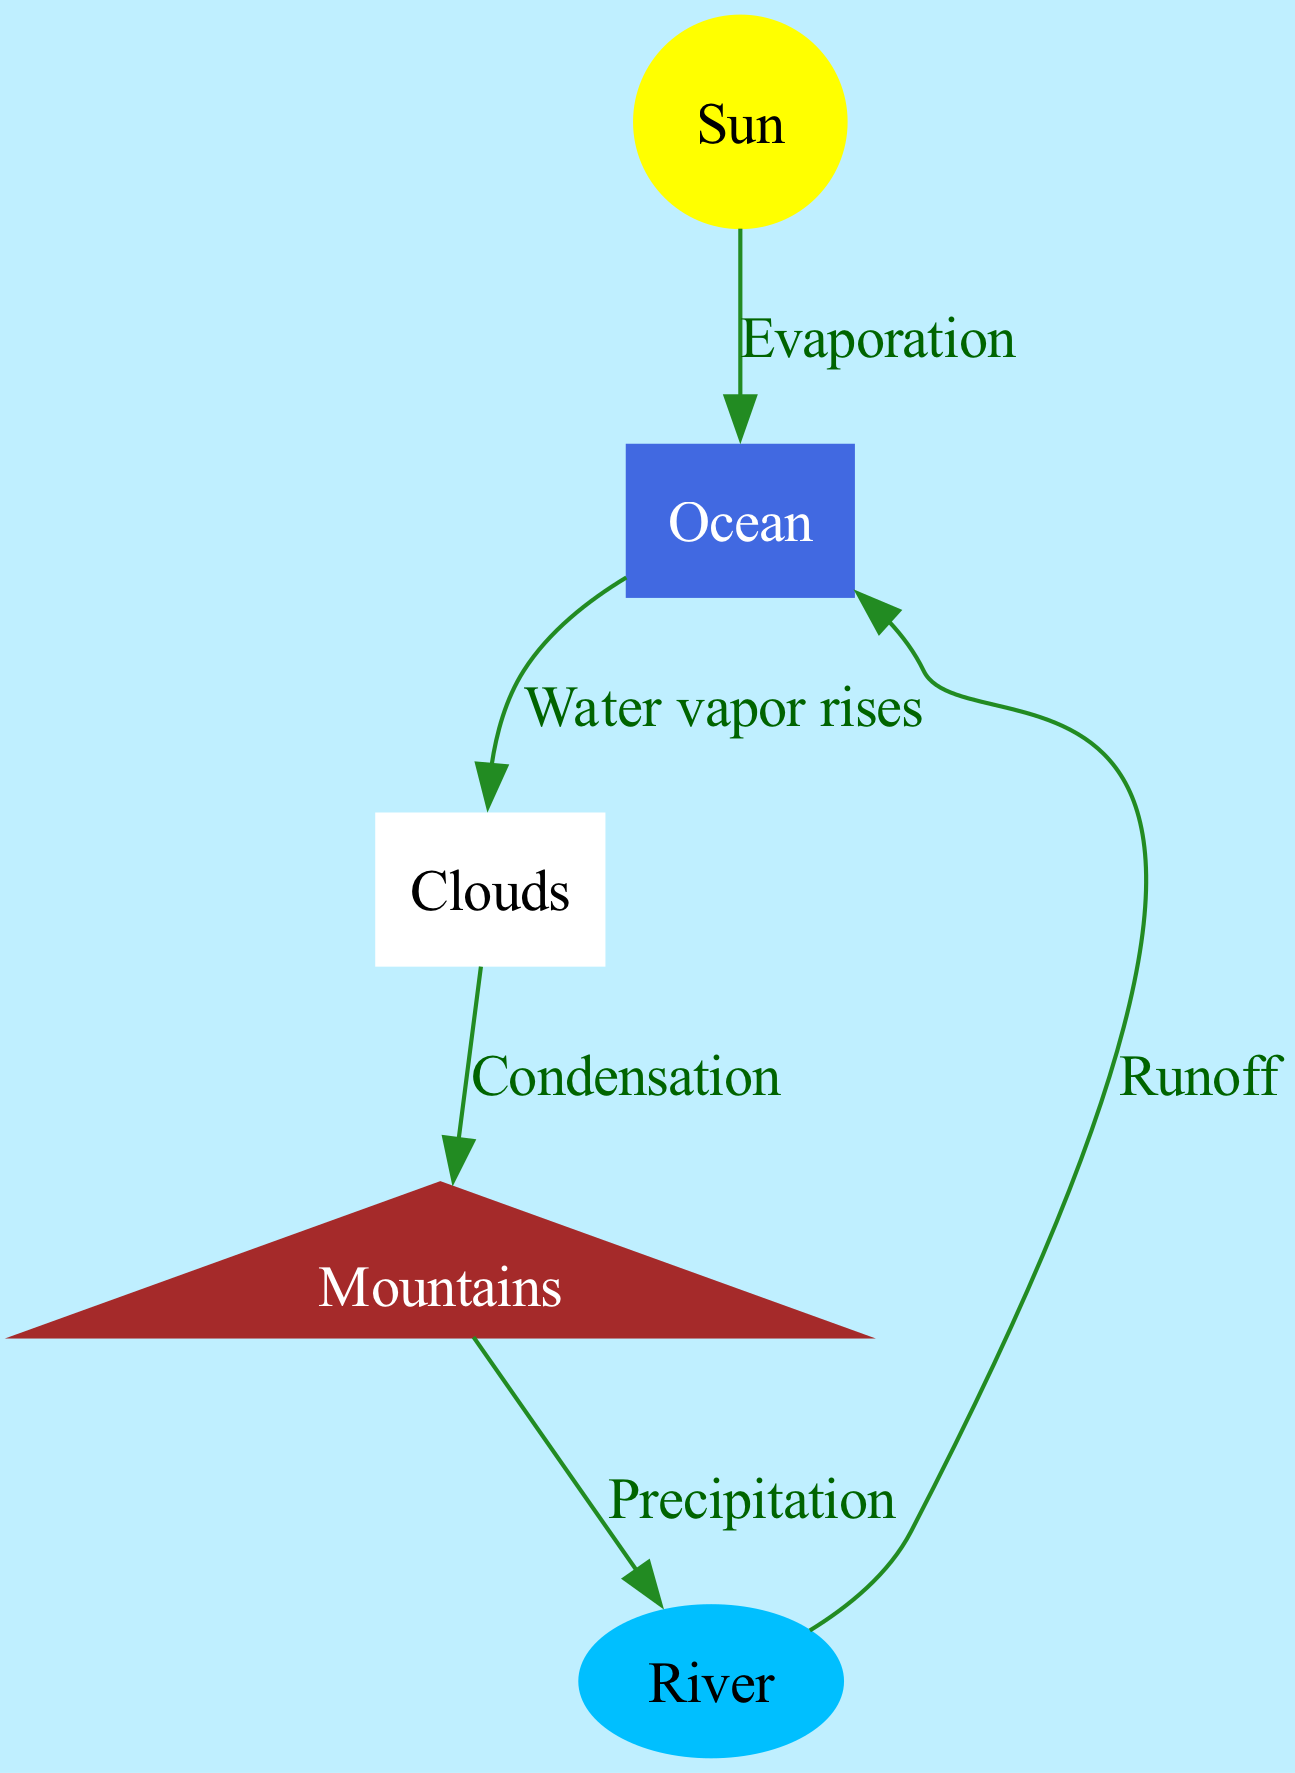What is the first process depicted in the water cycle? The diagram indicates that the first process is evaporation, which is shown with the edge labeled "Evaporation" connecting the Sun to the Ocean.
Answer: Evaporation How many nodes are represented in the diagram? The diagram consists of 5 nodes: Sun, Ocean, Clouds, Mountains, and River. Counting all these nodes gives a total of 5.
Answer: 5 What happens to water vapor after it rises from the Ocean? According to the diagram, after water vapor rises from the Ocean, it moves to the Clouds, as indicated by the edge labeled "Water vapor rises."
Answer: Clouds What process occurs between the Clouds and the Mountains? The diagram shows that the process occurring between the Clouds and the Mountains is called condensation, as specified by the edge labeled "Condensation."
Answer: Condensation Where does the water go after precipitation occurs in the Mountains? Following precipitation, the water flows into the River, which is indicated by the edge labeled "Precipitation" connecting the Mountains to the River.
Answer: River Which node represents the source of runoff in the diagram? The diagram illustrates that the source of runoff is the River, as it connects to the Ocean through the edge labeled "Runoff."
Answer: River What color represents the Ocean in the diagram? The diagram shows the Ocean in royal blue color as designated in the node styles for the Ocean.
Answer: Royal blue How does the water get from the River back to the Ocean? In the diagram, the water returns from the River to the Ocean through the process labeled as runoff, represented by the edge connecting these two nodes.
Answer: Runoff What is the final destination of water after it flows through the River? The final destination of the water after it flows through the River is the Ocean, as indicated by the edge labeled "Runoff" leading back to the Ocean.
Answer: Ocean 